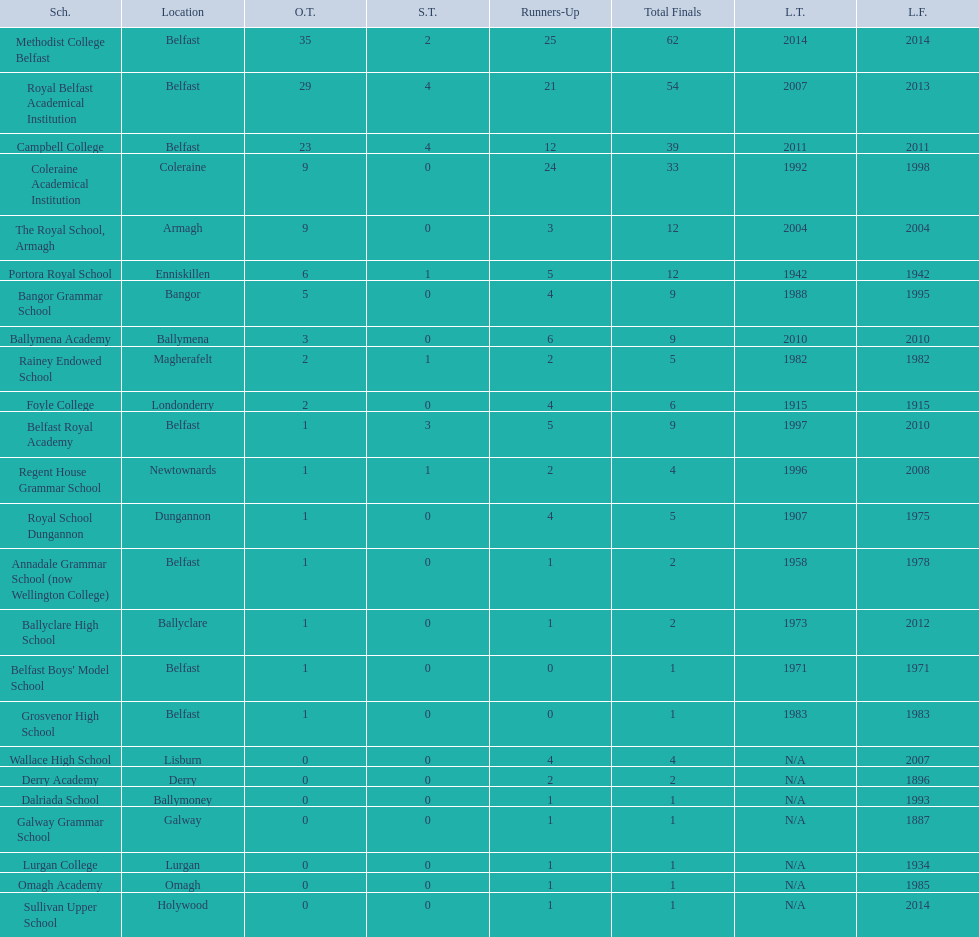How many schools are there? Methodist College Belfast, Royal Belfast Academical Institution, Campbell College, Coleraine Academical Institution, The Royal School, Armagh, Portora Royal School, Bangor Grammar School, Ballymena Academy, Rainey Endowed School, Foyle College, Belfast Royal Academy, Regent House Grammar School, Royal School Dungannon, Annadale Grammar School (now Wellington College), Ballyclare High School, Belfast Boys' Model School, Grosvenor High School, Wallace High School, Derry Academy, Dalriada School, Galway Grammar School, Lurgan College, Omagh Academy, Sullivan Upper School. How many outright titles does the coleraine academical institution have? 9. What other school has the same number of outright titles? The Royal School, Armagh. 